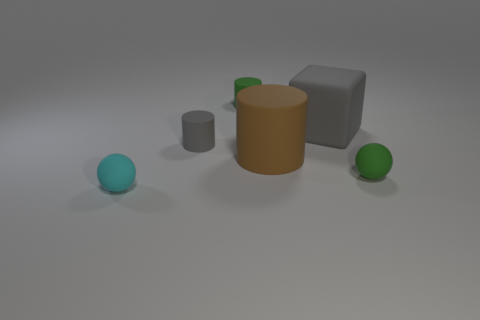Add 4 large cyan blocks. How many objects exist? 10 Subtract all cubes. How many objects are left? 5 Add 6 cyan rubber spheres. How many cyan rubber spheres exist? 7 Subtract 1 brown cylinders. How many objects are left? 5 Subtract all rubber spheres. Subtract all small cyan objects. How many objects are left? 3 Add 3 brown matte cylinders. How many brown matte cylinders are left? 4 